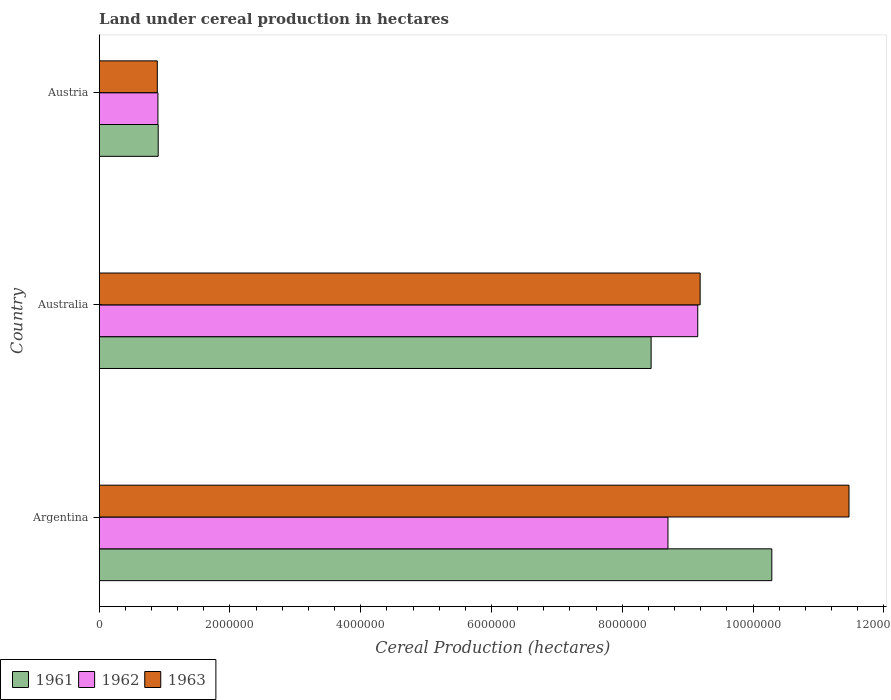How many bars are there on the 2nd tick from the bottom?
Keep it short and to the point. 3. In how many cases, is the number of bars for a given country not equal to the number of legend labels?
Give a very brief answer. 0. What is the land under cereal production in 1962 in Argentina?
Your response must be concise. 8.70e+06. Across all countries, what is the maximum land under cereal production in 1961?
Make the answer very short. 1.03e+07. Across all countries, what is the minimum land under cereal production in 1962?
Offer a very short reply. 8.98e+05. What is the total land under cereal production in 1962 in the graph?
Provide a succinct answer. 1.88e+07. What is the difference between the land under cereal production in 1962 in Australia and that in Austria?
Your response must be concise. 8.26e+06. What is the difference between the land under cereal production in 1963 in Argentina and the land under cereal production in 1962 in Australia?
Offer a terse response. 2.31e+06. What is the average land under cereal production in 1963 per country?
Provide a succinct answer. 7.18e+06. What is the difference between the land under cereal production in 1961 and land under cereal production in 1962 in Argentina?
Keep it short and to the point. 1.59e+06. In how many countries, is the land under cereal production in 1961 greater than 1200000 hectares?
Keep it short and to the point. 2. What is the ratio of the land under cereal production in 1962 in Argentina to that in Austria?
Your answer should be very brief. 9.69. Is the land under cereal production in 1963 in Australia less than that in Austria?
Offer a terse response. No. Is the difference between the land under cereal production in 1961 in Argentina and Austria greater than the difference between the land under cereal production in 1962 in Argentina and Austria?
Keep it short and to the point. Yes. What is the difference between the highest and the second highest land under cereal production in 1961?
Keep it short and to the point. 1.85e+06. What is the difference between the highest and the lowest land under cereal production in 1963?
Offer a very short reply. 1.06e+07. In how many countries, is the land under cereal production in 1961 greater than the average land under cereal production in 1961 taken over all countries?
Your answer should be compact. 2. What does the 3rd bar from the top in Austria represents?
Provide a short and direct response. 1961. Is it the case that in every country, the sum of the land under cereal production in 1963 and land under cereal production in 1961 is greater than the land under cereal production in 1962?
Provide a short and direct response. Yes. How many bars are there?
Give a very brief answer. 9. How many countries are there in the graph?
Ensure brevity in your answer.  3. Are the values on the major ticks of X-axis written in scientific E-notation?
Your response must be concise. No. Does the graph contain grids?
Ensure brevity in your answer.  No. Where does the legend appear in the graph?
Provide a succinct answer. Bottom left. How many legend labels are there?
Make the answer very short. 3. How are the legend labels stacked?
Ensure brevity in your answer.  Horizontal. What is the title of the graph?
Your answer should be compact. Land under cereal production in hectares. What is the label or title of the X-axis?
Ensure brevity in your answer.  Cereal Production (hectares). What is the Cereal Production (hectares) in 1961 in Argentina?
Your answer should be compact. 1.03e+07. What is the Cereal Production (hectares) of 1962 in Argentina?
Give a very brief answer. 8.70e+06. What is the Cereal Production (hectares) in 1963 in Argentina?
Keep it short and to the point. 1.15e+07. What is the Cereal Production (hectares) in 1961 in Australia?
Provide a short and direct response. 8.44e+06. What is the Cereal Production (hectares) of 1962 in Australia?
Give a very brief answer. 9.15e+06. What is the Cereal Production (hectares) in 1963 in Australia?
Provide a short and direct response. 9.19e+06. What is the Cereal Production (hectares) in 1961 in Austria?
Provide a succinct answer. 9.02e+05. What is the Cereal Production (hectares) in 1962 in Austria?
Your answer should be very brief. 8.98e+05. What is the Cereal Production (hectares) in 1963 in Austria?
Give a very brief answer. 8.88e+05. Across all countries, what is the maximum Cereal Production (hectares) in 1961?
Give a very brief answer. 1.03e+07. Across all countries, what is the maximum Cereal Production (hectares) in 1962?
Offer a terse response. 9.15e+06. Across all countries, what is the maximum Cereal Production (hectares) in 1963?
Your answer should be compact. 1.15e+07. Across all countries, what is the minimum Cereal Production (hectares) in 1961?
Offer a very short reply. 9.02e+05. Across all countries, what is the minimum Cereal Production (hectares) of 1962?
Offer a terse response. 8.98e+05. Across all countries, what is the minimum Cereal Production (hectares) of 1963?
Provide a short and direct response. 8.88e+05. What is the total Cereal Production (hectares) in 1961 in the graph?
Provide a short and direct response. 1.96e+07. What is the total Cereal Production (hectares) in 1962 in the graph?
Offer a terse response. 1.88e+07. What is the total Cereal Production (hectares) of 1963 in the graph?
Provide a short and direct response. 2.15e+07. What is the difference between the Cereal Production (hectares) of 1961 in Argentina and that in Australia?
Your answer should be compact. 1.85e+06. What is the difference between the Cereal Production (hectares) in 1962 in Argentina and that in Australia?
Make the answer very short. -4.55e+05. What is the difference between the Cereal Production (hectares) of 1963 in Argentina and that in Australia?
Keep it short and to the point. 2.28e+06. What is the difference between the Cereal Production (hectares) of 1961 in Argentina and that in Austria?
Offer a terse response. 9.39e+06. What is the difference between the Cereal Production (hectares) of 1962 in Argentina and that in Austria?
Your answer should be very brief. 7.80e+06. What is the difference between the Cereal Production (hectares) in 1963 in Argentina and that in Austria?
Make the answer very short. 1.06e+07. What is the difference between the Cereal Production (hectares) in 1961 in Australia and that in Austria?
Keep it short and to the point. 7.54e+06. What is the difference between the Cereal Production (hectares) in 1962 in Australia and that in Austria?
Offer a very short reply. 8.26e+06. What is the difference between the Cereal Production (hectares) of 1963 in Australia and that in Austria?
Offer a very short reply. 8.30e+06. What is the difference between the Cereal Production (hectares) in 1961 in Argentina and the Cereal Production (hectares) in 1962 in Australia?
Make the answer very short. 1.13e+06. What is the difference between the Cereal Production (hectares) of 1961 in Argentina and the Cereal Production (hectares) of 1963 in Australia?
Keep it short and to the point. 1.10e+06. What is the difference between the Cereal Production (hectares) of 1962 in Argentina and the Cereal Production (hectares) of 1963 in Australia?
Your answer should be compact. -4.92e+05. What is the difference between the Cereal Production (hectares) of 1961 in Argentina and the Cereal Production (hectares) of 1962 in Austria?
Your answer should be compact. 9.39e+06. What is the difference between the Cereal Production (hectares) of 1961 in Argentina and the Cereal Production (hectares) of 1963 in Austria?
Your response must be concise. 9.40e+06. What is the difference between the Cereal Production (hectares) in 1962 in Argentina and the Cereal Production (hectares) in 1963 in Austria?
Make the answer very short. 7.81e+06. What is the difference between the Cereal Production (hectares) of 1961 in Australia and the Cereal Production (hectares) of 1962 in Austria?
Make the answer very short. 7.54e+06. What is the difference between the Cereal Production (hectares) of 1961 in Australia and the Cereal Production (hectares) of 1963 in Austria?
Your answer should be very brief. 7.55e+06. What is the difference between the Cereal Production (hectares) in 1962 in Australia and the Cereal Production (hectares) in 1963 in Austria?
Provide a succinct answer. 8.27e+06. What is the average Cereal Production (hectares) in 1961 per country?
Provide a succinct answer. 6.54e+06. What is the average Cereal Production (hectares) in 1962 per country?
Provide a succinct answer. 6.25e+06. What is the average Cereal Production (hectares) in 1963 per country?
Give a very brief answer. 7.18e+06. What is the difference between the Cereal Production (hectares) in 1961 and Cereal Production (hectares) in 1962 in Argentina?
Your response must be concise. 1.59e+06. What is the difference between the Cereal Production (hectares) of 1961 and Cereal Production (hectares) of 1963 in Argentina?
Your response must be concise. -1.18e+06. What is the difference between the Cereal Production (hectares) in 1962 and Cereal Production (hectares) in 1963 in Argentina?
Offer a terse response. -2.77e+06. What is the difference between the Cereal Production (hectares) of 1961 and Cereal Production (hectares) of 1962 in Australia?
Ensure brevity in your answer.  -7.13e+05. What is the difference between the Cereal Production (hectares) in 1961 and Cereal Production (hectares) in 1963 in Australia?
Provide a succinct answer. -7.50e+05. What is the difference between the Cereal Production (hectares) of 1962 and Cereal Production (hectares) of 1963 in Australia?
Give a very brief answer. -3.66e+04. What is the difference between the Cereal Production (hectares) in 1961 and Cereal Production (hectares) in 1962 in Austria?
Offer a very short reply. 4295. What is the difference between the Cereal Production (hectares) in 1961 and Cereal Production (hectares) in 1963 in Austria?
Your answer should be compact. 1.38e+04. What is the difference between the Cereal Production (hectares) in 1962 and Cereal Production (hectares) in 1963 in Austria?
Offer a very short reply. 9525. What is the ratio of the Cereal Production (hectares) in 1961 in Argentina to that in Australia?
Give a very brief answer. 1.22. What is the ratio of the Cereal Production (hectares) of 1962 in Argentina to that in Australia?
Provide a succinct answer. 0.95. What is the ratio of the Cereal Production (hectares) in 1963 in Argentina to that in Australia?
Your response must be concise. 1.25. What is the ratio of the Cereal Production (hectares) of 1961 in Argentina to that in Austria?
Provide a short and direct response. 11.4. What is the ratio of the Cereal Production (hectares) of 1962 in Argentina to that in Austria?
Your answer should be very brief. 9.69. What is the ratio of the Cereal Production (hectares) of 1963 in Argentina to that in Austria?
Give a very brief answer. 12.91. What is the ratio of the Cereal Production (hectares) of 1961 in Australia to that in Austria?
Keep it short and to the point. 9.36. What is the ratio of the Cereal Production (hectares) of 1962 in Australia to that in Austria?
Ensure brevity in your answer.  10.2. What is the ratio of the Cereal Production (hectares) in 1963 in Australia to that in Austria?
Give a very brief answer. 10.35. What is the difference between the highest and the second highest Cereal Production (hectares) in 1961?
Your answer should be very brief. 1.85e+06. What is the difference between the highest and the second highest Cereal Production (hectares) in 1962?
Keep it short and to the point. 4.55e+05. What is the difference between the highest and the second highest Cereal Production (hectares) in 1963?
Offer a terse response. 2.28e+06. What is the difference between the highest and the lowest Cereal Production (hectares) of 1961?
Make the answer very short. 9.39e+06. What is the difference between the highest and the lowest Cereal Production (hectares) in 1962?
Your response must be concise. 8.26e+06. What is the difference between the highest and the lowest Cereal Production (hectares) of 1963?
Ensure brevity in your answer.  1.06e+07. 